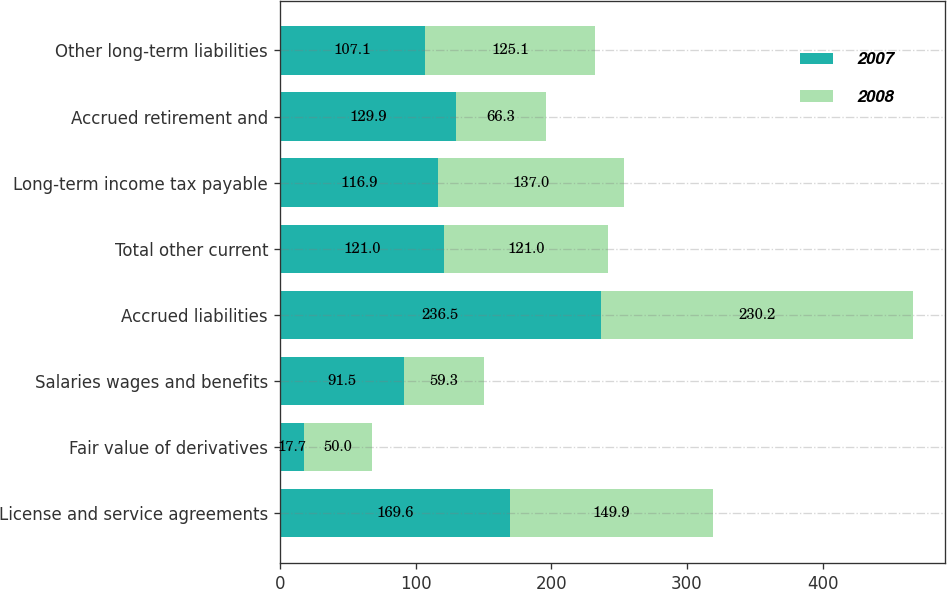<chart> <loc_0><loc_0><loc_500><loc_500><stacked_bar_chart><ecel><fcel>License and service agreements<fcel>Fair value of derivatives<fcel>Salaries wages and benefits<fcel>Accrued liabilities<fcel>Total other current<fcel>Long-term income tax payable<fcel>Accrued retirement and<fcel>Other long-term liabilities<nl><fcel>2007<fcel>169.6<fcel>17.7<fcel>91.5<fcel>236.5<fcel>121<fcel>116.9<fcel>129.9<fcel>107.1<nl><fcel>2008<fcel>149.9<fcel>50<fcel>59.3<fcel>230.2<fcel>121<fcel>137<fcel>66.3<fcel>125.1<nl></chart> 